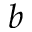<formula> <loc_0><loc_0><loc_500><loc_500>^ { b }</formula> 